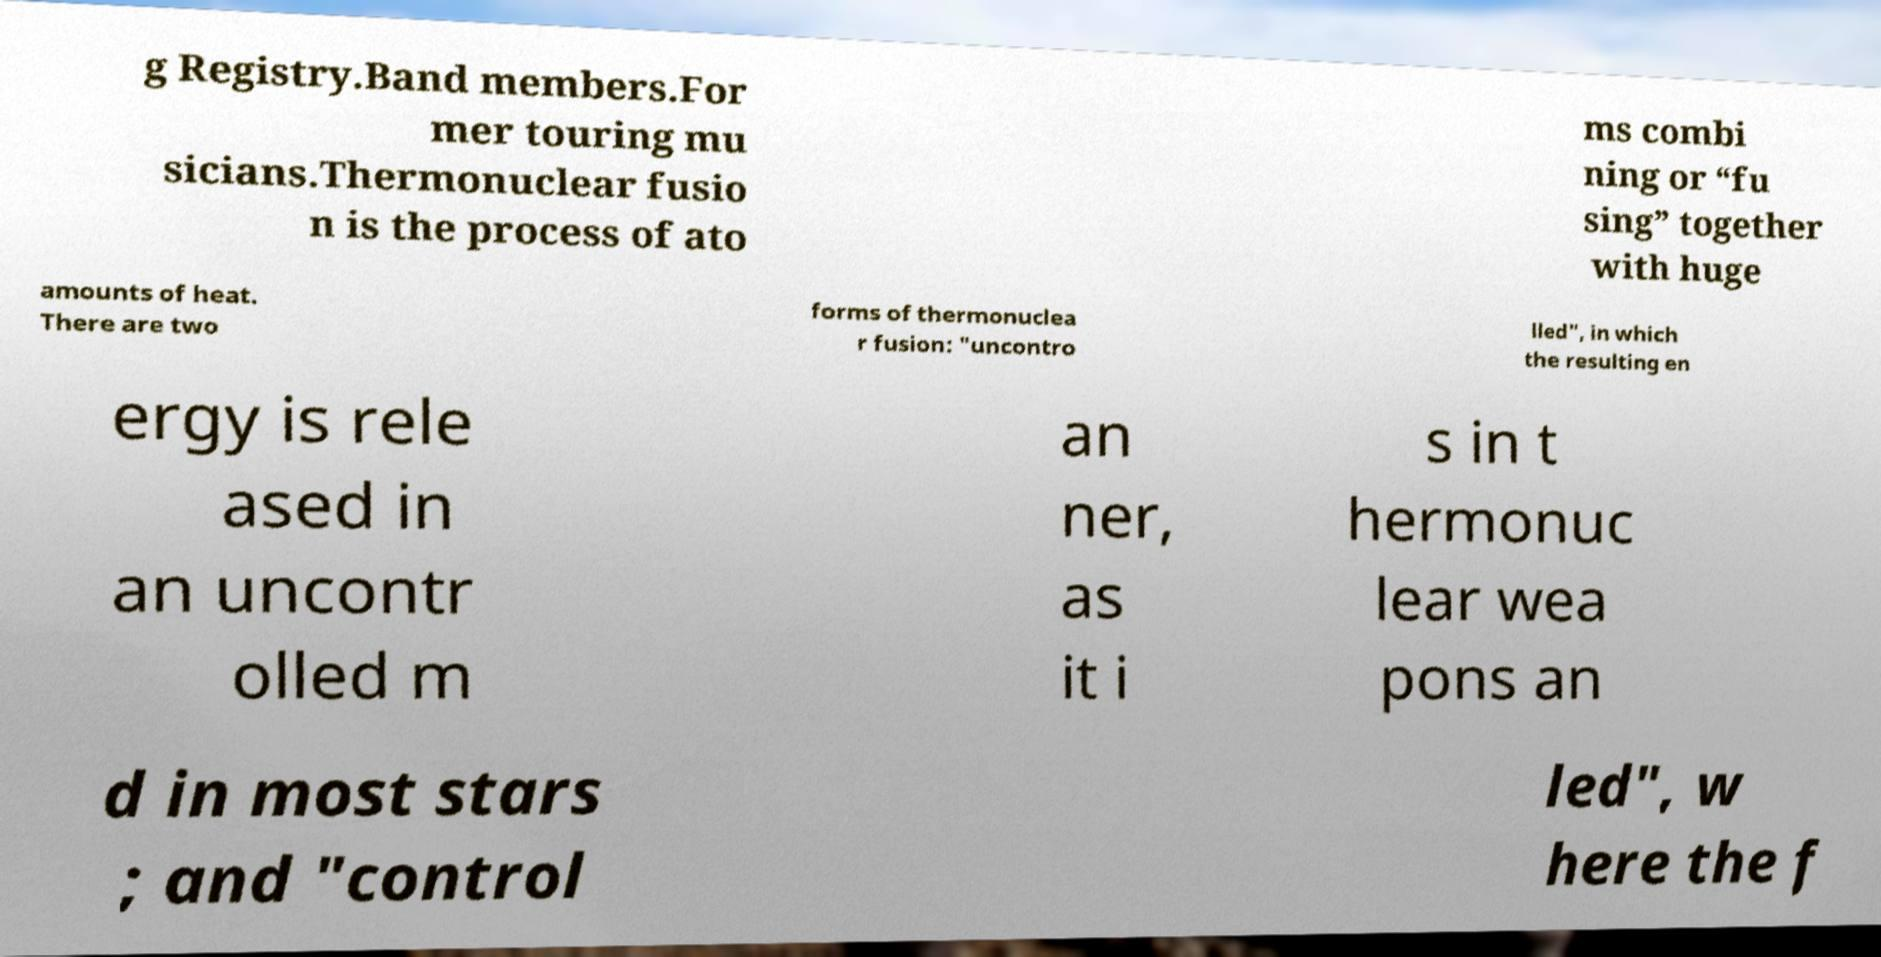I need the written content from this picture converted into text. Can you do that? g Registry.Band members.For mer touring mu sicians.Thermonuclear fusio n is the process of ato ms combi ning or “fu sing” together with huge amounts of heat. There are two forms of thermonuclea r fusion: "uncontro lled", in which the resulting en ergy is rele ased in an uncontr olled m an ner, as it i s in t hermonuc lear wea pons an d in most stars ; and "control led", w here the f 